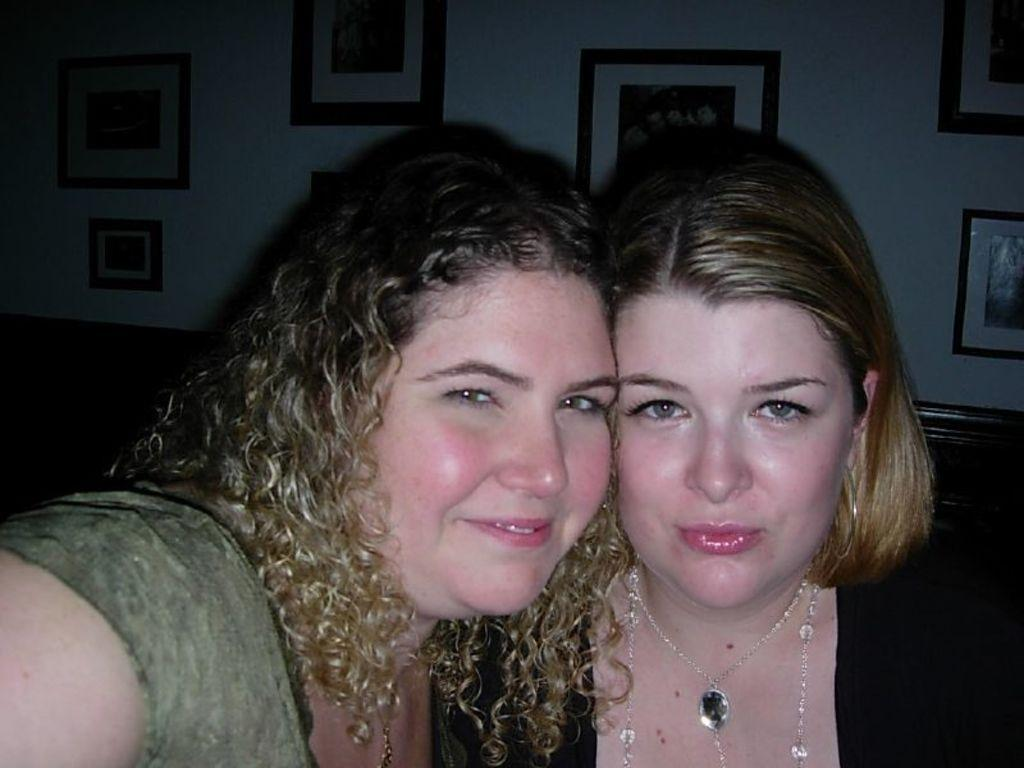How many people are in the image? There are two women in the image. What is the facial expression of the women? The women are smiling. What can be seen on the wall in the background of the image? There are frames on the wall in the background of the image. What type of pan is being used by the women in the image? There is no pan present in the image; it features two women who are smiling. What kind of pet can be seen interacting with the women in the image? There is no pet present in the image; it only shows two women who are smiling. 